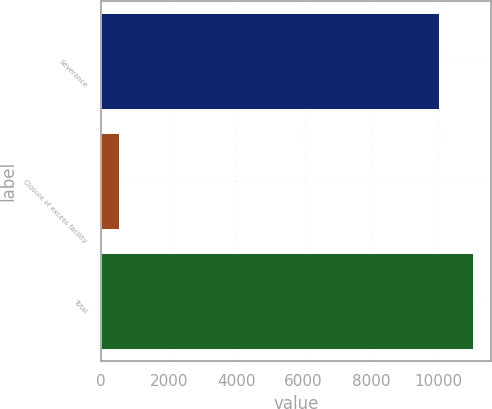Convert chart. <chart><loc_0><loc_0><loc_500><loc_500><bar_chart><fcel>Severance<fcel>Closure of excess facility<fcel>Total<nl><fcel>10009<fcel>522<fcel>11009.9<nl></chart> 